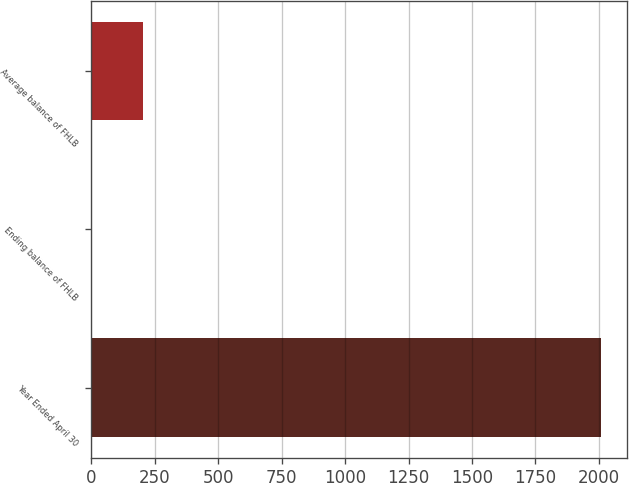<chart> <loc_0><loc_0><loc_500><loc_500><bar_chart><fcel>Year Ended April 30<fcel>Ending balance of FHLB<fcel>Average balance of FHLB<nl><fcel>2010<fcel>1.92<fcel>202.73<nl></chart> 